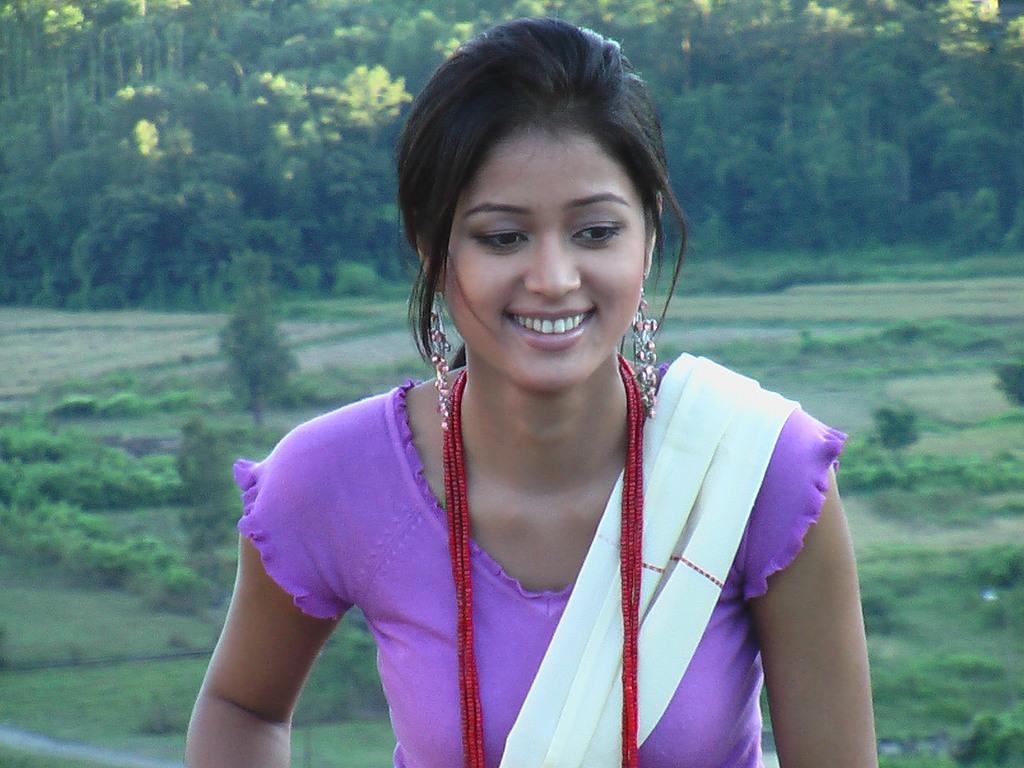Who is present in the image? There is a woman in the image. What type of natural environment can be seen in the image? There is grass, plants, and trees visible in the image. What type of sleet is falling on the woman in the image? There is no sleet present in the image; it is a clear day with grass, plants, and trees visible. 